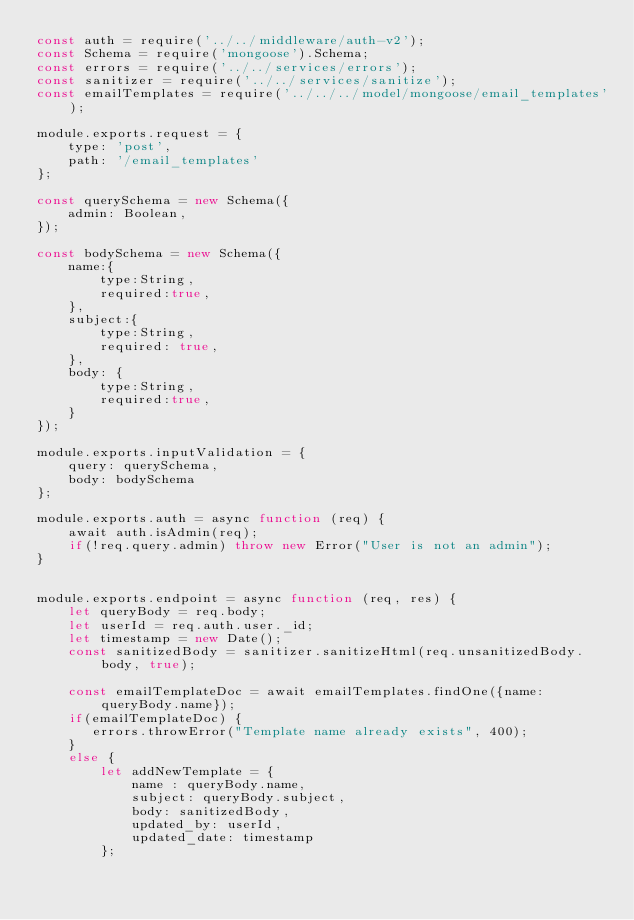Convert code to text. <code><loc_0><loc_0><loc_500><loc_500><_JavaScript_>const auth = require('../../middleware/auth-v2');
const Schema = require('mongoose').Schema;
const errors = require('../../services/errors');
const sanitizer = require('../../services/sanitize');
const emailTemplates = require('../../../model/mongoose/email_templates');

module.exports.request = {
    type: 'post',
    path: '/email_templates'
};

const querySchema = new Schema({
    admin: Boolean,
});

const bodySchema = new Schema({
    name:{
        type:String,
        required:true,
    },
    subject:{
        type:String,
        required: true,
    },
    body: {
        type:String,
        required:true,
    }
});

module.exports.inputValidation = {
    query: querySchema,
    body: bodySchema
};

module.exports.auth = async function (req) {
    await auth.isAdmin(req);
    if(!req.query.admin) throw new Error("User is not an admin");
}


module.exports.endpoint = async function (req, res) {
    let queryBody = req.body;
    let userId = req.auth.user._id;
    let timestamp = new Date();
    const sanitizedBody = sanitizer.sanitizeHtml(req.unsanitizedBody.body, true);

    const emailTemplateDoc = await emailTemplates.findOne({name: queryBody.name});
    if(emailTemplateDoc) {
       errors.throwError("Template name already exists", 400);
    }
    else {
        let addNewTemplate = {
            name : queryBody.name,
            subject: queryBody.subject,
            body: sanitizedBody,
            updated_by: userId,
            updated_date: timestamp
        };</code> 